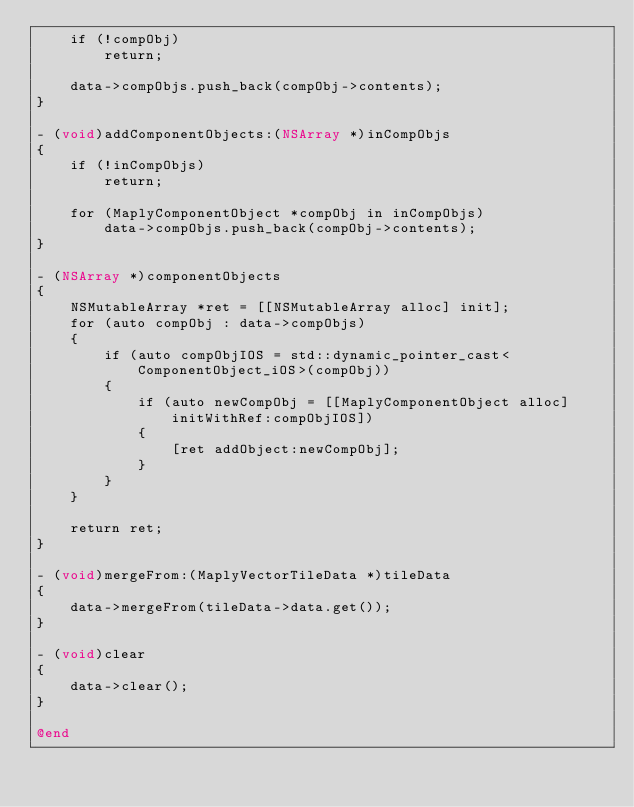Convert code to text. <code><loc_0><loc_0><loc_500><loc_500><_ObjectiveC_>    if (!compObj)
        return;
    
    data->compObjs.push_back(compObj->contents);
}

- (void)addComponentObjects:(NSArray *)inCompObjs
{
    if (!inCompObjs)
        return;

    for (MaplyComponentObject *compObj in inCompObjs)
        data->compObjs.push_back(compObj->contents);
}

- (NSArray *)componentObjects
{
    NSMutableArray *ret = [[NSMutableArray alloc] init];
    for (auto compObj : data->compObjs)
    {
        if (auto compObjIOS = std::dynamic_pointer_cast<ComponentObject_iOS>(compObj))
        {
            if (auto newCompObj = [[MaplyComponentObject alloc] initWithRef:compObjIOS])
            {
                [ret addObject:newCompObj];
            }
        }
    }
    
    return ret;
}

- (void)mergeFrom:(MaplyVectorTileData *)tileData
{
    data->mergeFrom(tileData->data.get());
}

- (void)clear
{
    data->clear();
}

@end
</code> 